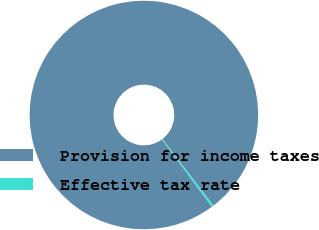Convert chart to OTSL. <chart><loc_0><loc_0><loc_500><loc_500><pie_chart><fcel>Provision for income taxes<fcel>Effective tax rate<nl><fcel>99.71%<fcel>0.29%<nl></chart> 